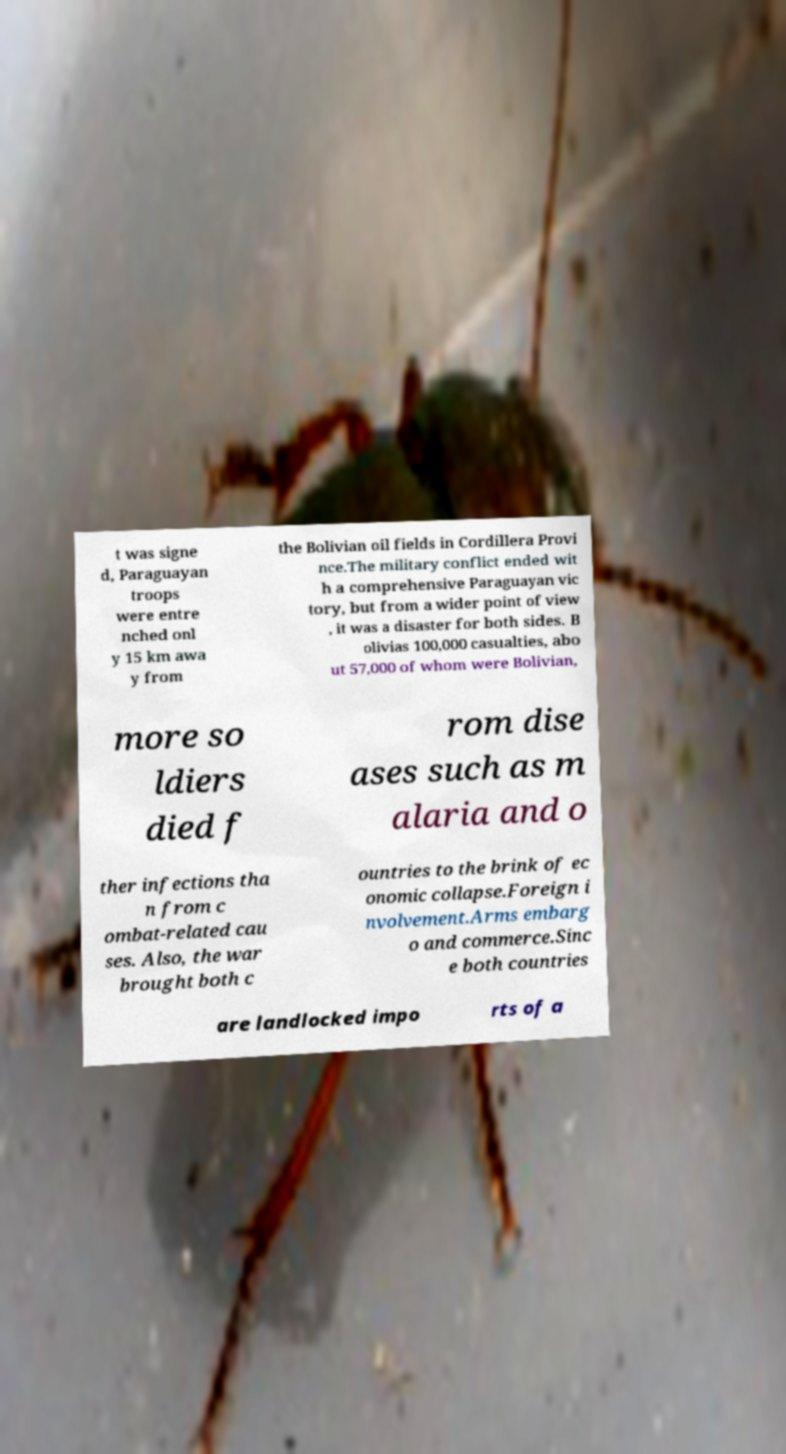Could you extract and type out the text from this image? t was signe d, Paraguayan troops were entre nched onl y 15 km awa y from the Bolivian oil fields in Cordillera Provi nce.The military conflict ended wit h a comprehensive Paraguayan vic tory, but from a wider point of view , it was a disaster for both sides. B olivias 100,000 casualties, abo ut 57,000 of whom were Bolivian, more so ldiers died f rom dise ases such as m alaria and o ther infections tha n from c ombat-related cau ses. Also, the war brought both c ountries to the brink of ec onomic collapse.Foreign i nvolvement.Arms embarg o and commerce.Sinc e both countries are landlocked impo rts of a 